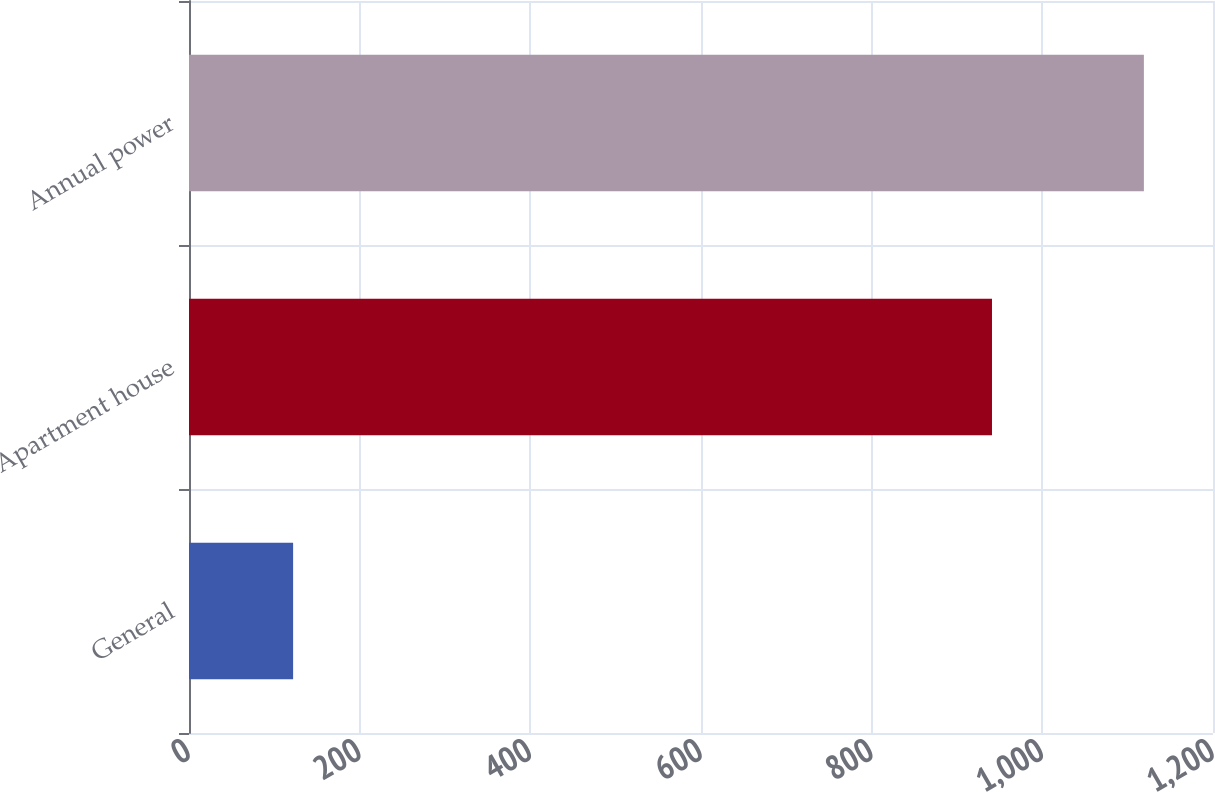<chart> <loc_0><loc_0><loc_500><loc_500><bar_chart><fcel>General<fcel>Apartment house<fcel>Annual power<nl><fcel>122<fcel>941<fcel>1119<nl></chart> 